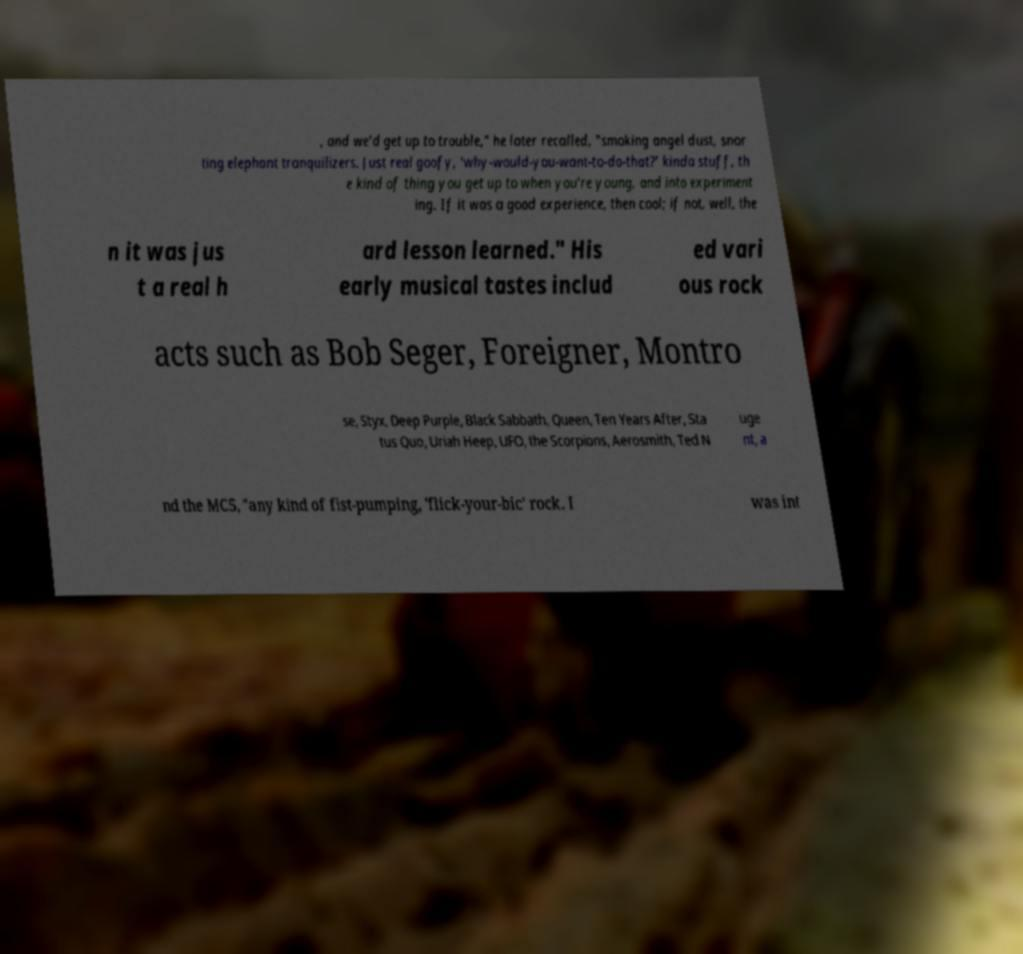For documentation purposes, I need the text within this image transcribed. Could you provide that? , and we'd get up to trouble," he later recalled, "smoking angel dust, snor ting elephant tranquilizers. Just real goofy, 'why-would-you-want-to-do-that?' kinda stuff, th e kind of thing you get up to when you're young, and into experiment ing. If it was a good experience, then cool; if not, well, the n it was jus t a real h ard lesson learned." His early musical tastes includ ed vari ous rock acts such as Bob Seger, Foreigner, Montro se, Styx, Deep Purple, Black Sabbath, Queen, Ten Years After, Sta tus Quo, Uriah Heep, UFO, the Scorpions, Aerosmith, Ted N uge nt, a nd the MC5, "any kind of fist-pumping, 'flick-your-bic' rock. I was int 